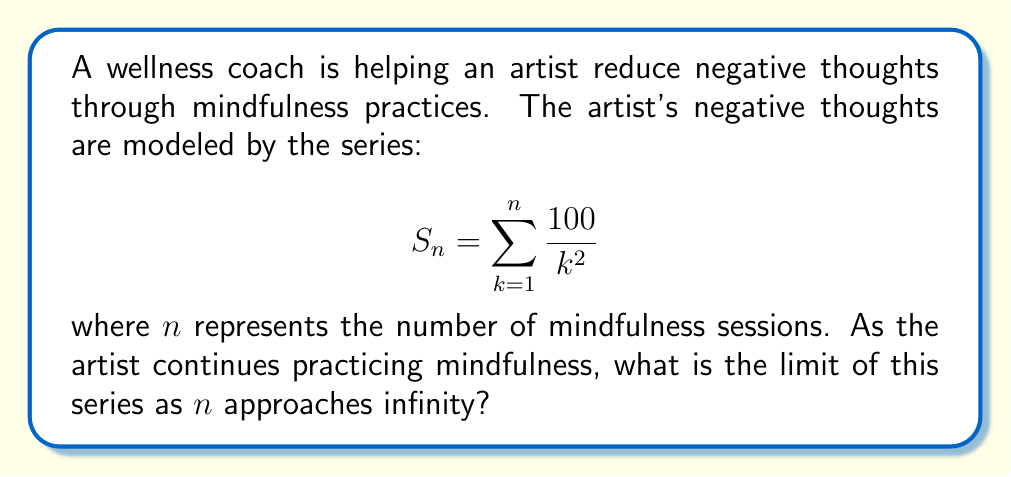Could you help me with this problem? To find the limit of this series as $n$ approaches infinity, we need to follow these steps:

1) Recognize the series:
   This is a p-series of the form $\sum_{k=1}^{\infty} \frac{1}{k^p}$ where $p = 2$.

2) Recall the convergence of p-series:
   A p-series converges if and only if $p > 1$.

3) Check convergence:
   In this case, $p = 2$, which is greater than 1, so the series converges.

4) Identify the specific series:
   This is a scaled version of the Basel problem series $\sum_{k=1}^{\infty} \frac{1}{k^2}$.

5) Recall the sum of the Basel problem:
   $$\sum_{k=1}^{\infty} \frac{1}{k^2} = \frac{\pi^2}{6}$$

6) Apply scaling:
   Our series is 100 times the Basel problem series, so:
   $$\lim_{n \to \infty} S_n = 100 \cdot \frac{\pi^2}{6} = \frac{100\pi^2}{6}$$

7) Simplify:
   $$\frac{100\pi^2}{6} \approx 164.493$$

This result represents the total "amount" of negative thoughts that the artist would experience if continuing the mindfulness practice indefinitely, showing how the negative thoughts diminish and converge to a finite limit.
Answer: $\frac{100\pi^2}{6}$ 